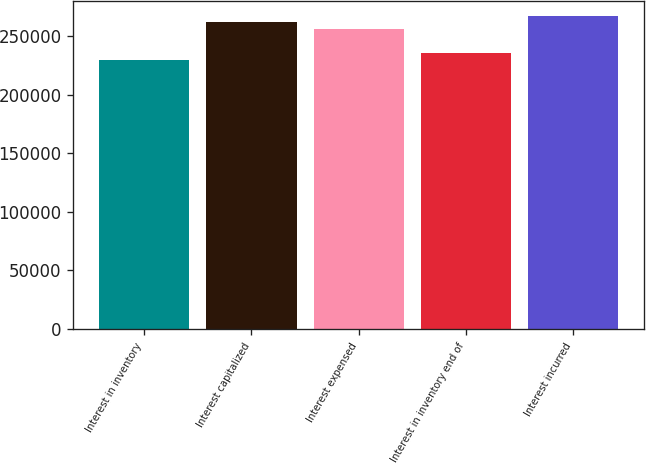Convert chart to OTSL. <chart><loc_0><loc_0><loc_500><loc_500><bar_chart><fcel>Interest in inventory<fcel>Interest capitalized<fcel>Interest expensed<fcel>Interest in inventory end of<fcel>Interest incurred<nl><fcel>229798<fcel>261486<fcel>255688<fcel>235596<fcel>266561<nl></chart> 